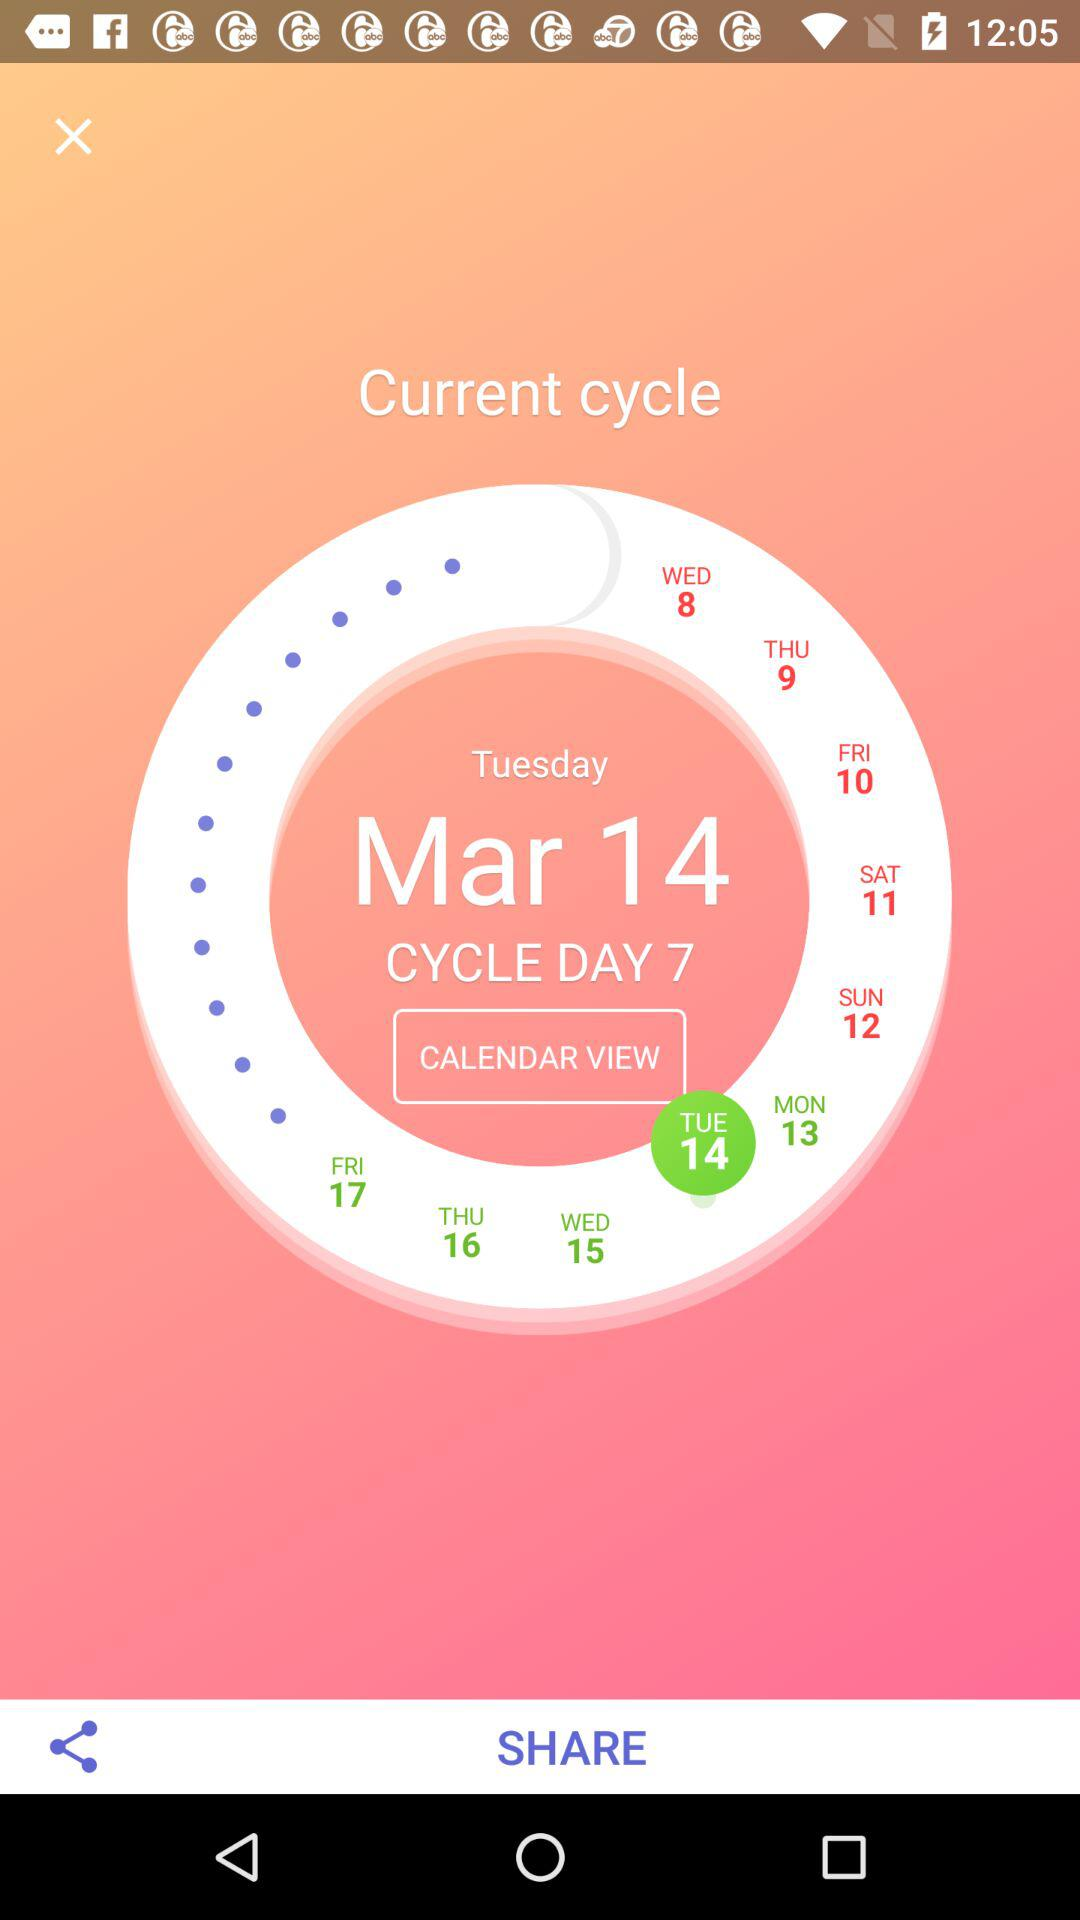Which applications are available for sharing?
When the provided information is insufficient, respond with <no answer>. <no answer> 